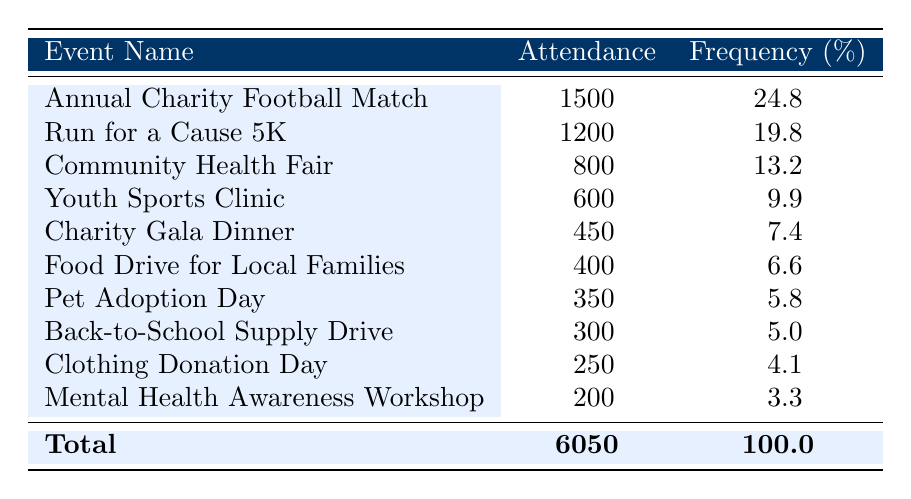What was the attendance at the Annual Charity Football Match? The table directly lists the attendance for each event. For the Annual Charity Football Match, the attendance is clearly indicated as 1500.
Answer: 1500 Which event had the highest attendance? By examining the attendance figures in the table, the highest number is found for the Annual Charity Football Match, which has an attendance of 1500, making it the event with the highest turnout.
Answer: Annual Charity Football Match How many people attended the Community Health Fair? The table provides the attendance figure for the Community Health Fair, which is shown as 800. Therefore, the number of attendees for this event is straightforward.
Answer: 800 What is the sum of attendees for the Youth Sports Clinic and the Charity Gala Dinner? To find the total, I add the attendance numbers from both events: Youth Sports Clinic has 600 attendees and Charity Gala Dinner has 450. The sum is 600 + 450 = 1050.
Answer: 1050 Is the attendance at the Mental Health Awareness Workshop greater than 200? The table indicates that the attendance at the Mental Health Awareness Workshop is 200. Therefore, it is not greater; it is equal to 200.
Answer: No What percentage of total attendance was from the Run for a Cause 5K event? The total attendance across all events is 6050. The attendance for the Run for a Cause 5K is 1200. To find the percentage, I calculate (1200/6050) * 100, which equals approximately 19.8%.
Answer: 19.8% Which two events had a combined attendance of less than 900? Looking for pairs of events, I see that the Clothing Donation Day (250) and Mental Health Awareness Workshop (200) combined total 450, which is less than 900. Therefore, they meet the criteria.
Answer: Clothing Donation Day and Mental Health Awareness Workshop How many events had an attendance greater than 600? From the table, I can count the events with attendance figures greater than 600. The events are the Annual Charity Football Match (1500), Run for a Cause 5K (1200), and Community Health Fair (800). There are three events in total that meet this criterion.
Answer: 3 What is the average attendance across all charity events? To calculate the average, I sum the attendance of all events (6050) and divide by the total number of events (10). The computation is 6050/10 = 605.
Answer: 605 